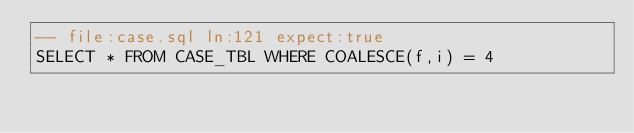<code> <loc_0><loc_0><loc_500><loc_500><_SQL_>-- file:case.sql ln:121 expect:true
SELECT * FROM CASE_TBL WHERE COALESCE(f,i) = 4
</code> 